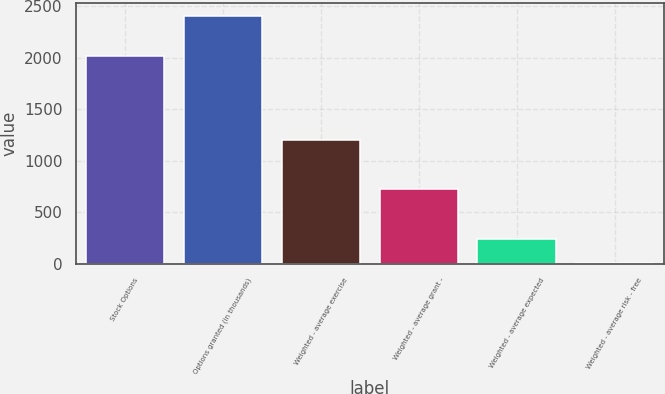<chart> <loc_0><loc_0><loc_500><loc_500><bar_chart><fcel>Stock Options<fcel>Options granted (in thousands)<fcel>Weighted - average exercise<fcel>Weighted - average grant -<fcel>Weighted - average expected<fcel>Weighted - average risk - free<nl><fcel>2013<fcel>2407<fcel>1204<fcel>722.8<fcel>241.6<fcel>1<nl></chart> 